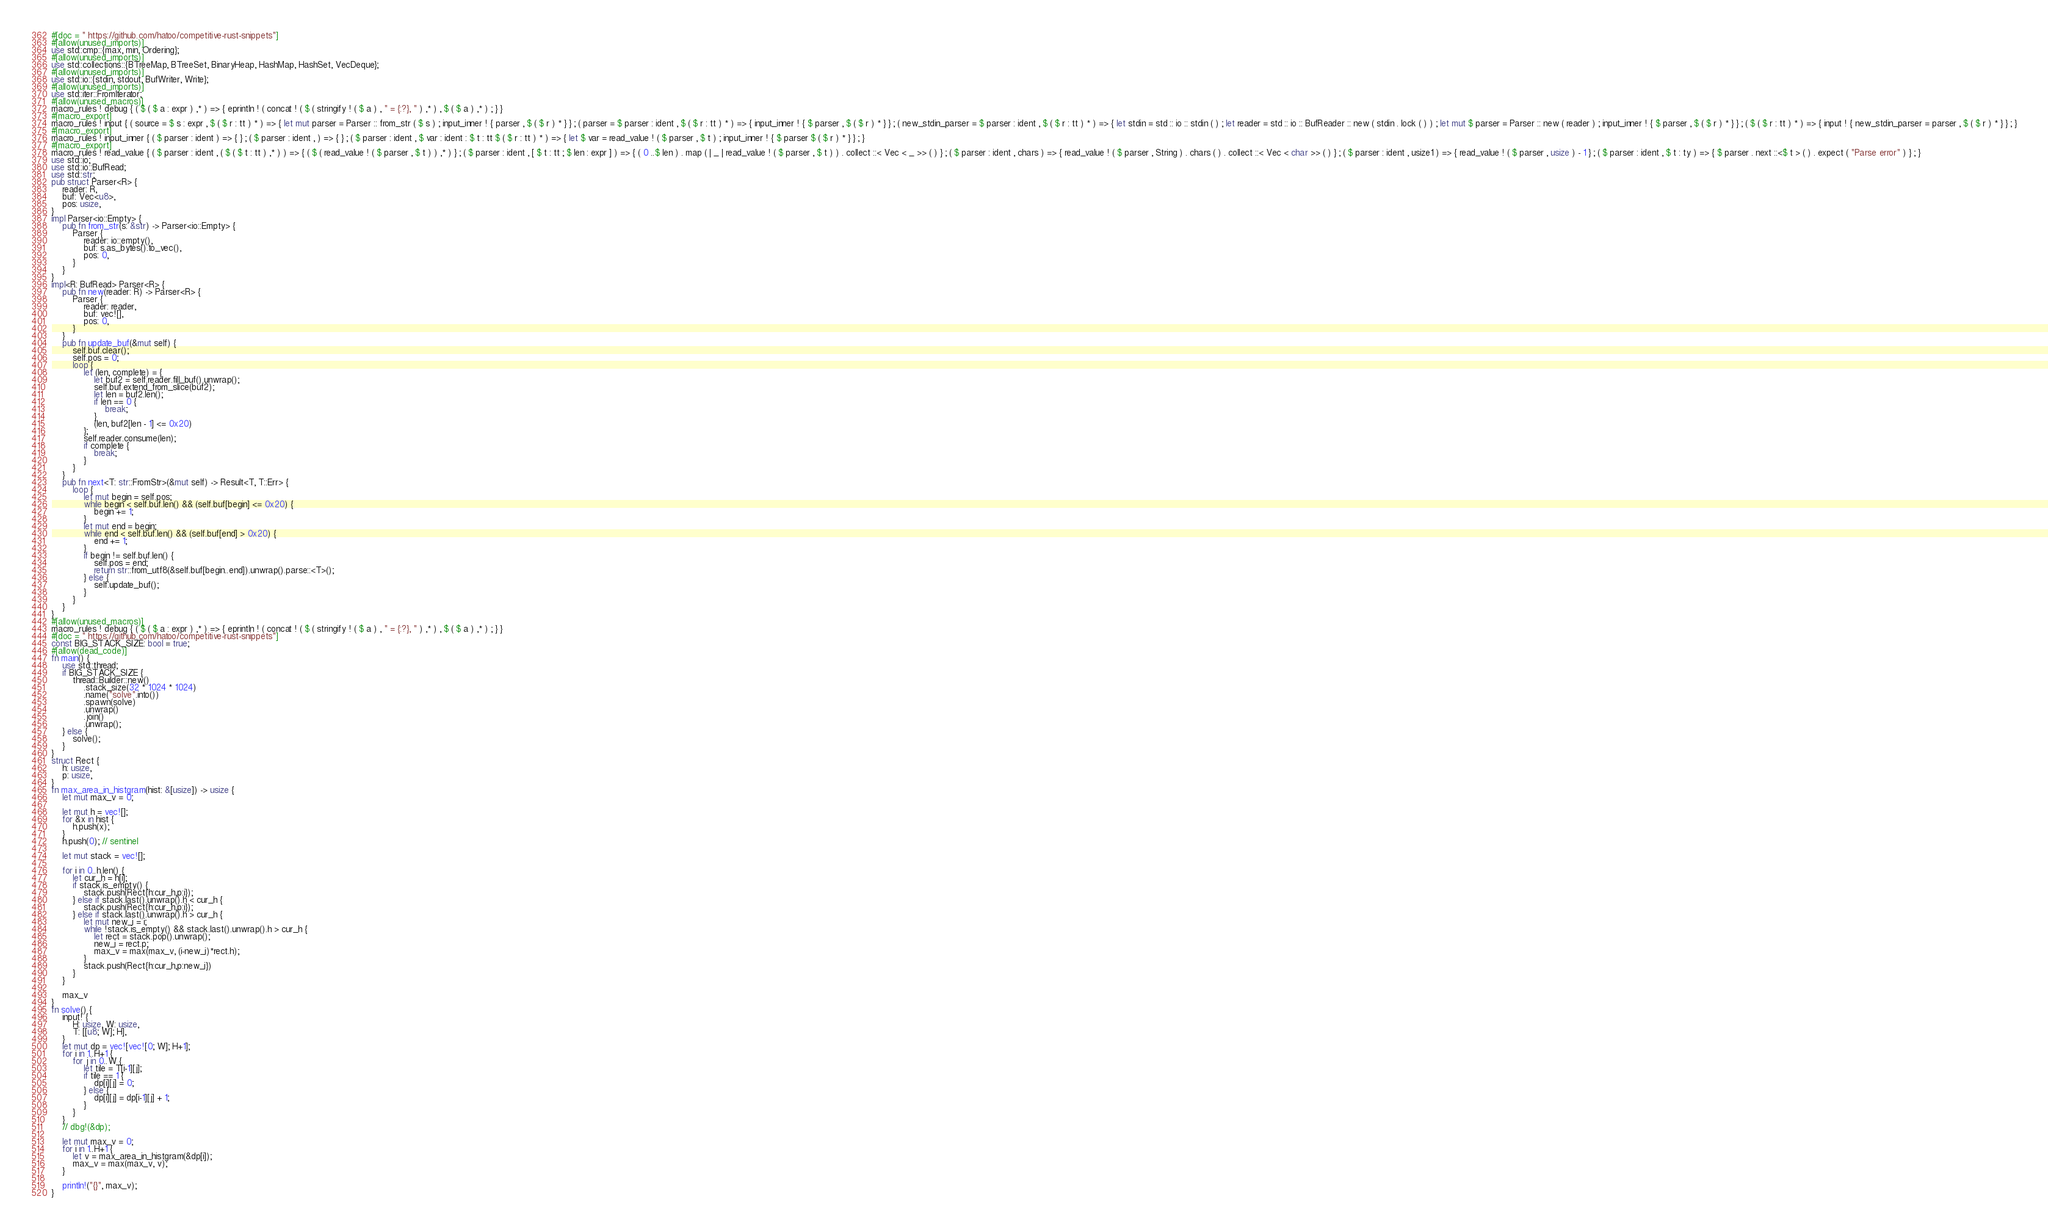<code> <loc_0><loc_0><loc_500><loc_500><_Rust_>#[doc = " https://github.com/hatoo/competitive-rust-snippets"]
#[allow(unused_imports)]
use std::cmp::{max, min, Ordering};
#[allow(unused_imports)]
use std::collections::{BTreeMap, BTreeSet, BinaryHeap, HashMap, HashSet, VecDeque};
#[allow(unused_imports)]
use std::io::{stdin, stdout, BufWriter, Write};
#[allow(unused_imports)]
use std::iter::FromIterator;
#[allow(unused_macros)]
macro_rules ! debug { ( $ ( $ a : expr ) ,* ) => { eprintln ! ( concat ! ( $ ( stringify ! ( $ a ) , " = {:?}, " ) ,* ) , $ ( $ a ) ,* ) ; } }
#[macro_export]
macro_rules ! input { ( source = $ s : expr , $ ( $ r : tt ) * ) => { let mut parser = Parser :: from_str ( $ s ) ; input_inner ! { parser , $ ( $ r ) * } } ; ( parser = $ parser : ident , $ ( $ r : tt ) * ) => { input_inner ! { $ parser , $ ( $ r ) * } } ; ( new_stdin_parser = $ parser : ident , $ ( $ r : tt ) * ) => { let stdin = std :: io :: stdin ( ) ; let reader = std :: io :: BufReader :: new ( stdin . lock ( ) ) ; let mut $ parser = Parser :: new ( reader ) ; input_inner ! { $ parser , $ ( $ r ) * } } ; ( $ ( $ r : tt ) * ) => { input ! { new_stdin_parser = parser , $ ( $ r ) * } } ; }
#[macro_export]
macro_rules ! input_inner { ( $ parser : ident ) => { } ; ( $ parser : ident , ) => { } ; ( $ parser : ident , $ var : ident : $ t : tt $ ( $ r : tt ) * ) => { let $ var = read_value ! ( $ parser , $ t ) ; input_inner ! { $ parser $ ( $ r ) * } } ; }
#[macro_export]
macro_rules ! read_value { ( $ parser : ident , ( $ ( $ t : tt ) ,* ) ) => { ( $ ( read_value ! ( $ parser , $ t ) ) ,* ) } ; ( $ parser : ident , [ $ t : tt ; $ len : expr ] ) => { ( 0 ..$ len ) . map ( | _ | read_value ! ( $ parser , $ t ) ) . collect ::< Vec < _ >> ( ) } ; ( $ parser : ident , chars ) => { read_value ! ( $ parser , String ) . chars ( ) . collect ::< Vec < char >> ( ) } ; ( $ parser : ident , usize1 ) => { read_value ! ( $ parser , usize ) - 1 } ; ( $ parser : ident , $ t : ty ) => { $ parser . next ::<$ t > ( ) . expect ( "Parse error" ) } ; }
use std::io;
use std::io::BufRead;
use std::str;
pub struct Parser<R> {
    reader: R,
    buf: Vec<u8>,
    pos: usize,
}
impl Parser<io::Empty> {
    pub fn from_str(s: &str) -> Parser<io::Empty> {
        Parser {
            reader: io::empty(),
            buf: s.as_bytes().to_vec(),
            pos: 0,
        }
    }
}
impl<R: BufRead> Parser<R> {
    pub fn new(reader: R) -> Parser<R> {
        Parser {
            reader: reader,
            buf: vec![],
            pos: 0,
        }
    }
    pub fn update_buf(&mut self) {
        self.buf.clear();
        self.pos = 0;
        loop {
            let (len, complete) = {
                let buf2 = self.reader.fill_buf().unwrap();
                self.buf.extend_from_slice(buf2);
                let len = buf2.len();
                if len == 0 {
                    break;
                }
                (len, buf2[len - 1] <= 0x20)
            };
            self.reader.consume(len);
            if complete {
                break;
            }
        }
    }
    pub fn next<T: str::FromStr>(&mut self) -> Result<T, T::Err> {
        loop {
            let mut begin = self.pos;
            while begin < self.buf.len() && (self.buf[begin] <= 0x20) {
                begin += 1;
            }
            let mut end = begin;
            while end < self.buf.len() && (self.buf[end] > 0x20) {
                end += 1;
            }
            if begin != self.buf.len() {
                self.pos = end;
                return str::from_utf8(&self.buf[begin..end]).unwrap().parse::<T>();
            } else {
                self.update_buf();
            }
        }
    }
}
#[allow(unused_macros)]
macro_rules ! debug { ( $ ( $ a : expr ) ,* ) => { eprintln ! ( concat ! ( $ ( stringify ! ( $ a ) , " = {:?}, " ) ,* ) , $ ( $ a ) ,* ) ; } }
#[doc = " https://github.com/hatoo/competitive-rust-snippets"]
const BIG_STACK_SIZE: bool = true;
#[allow(dead_code)]
fn main() {
    use std::thread;
    if BIG_STACK_SIZE {
        thread::Builder::new()
            .stack_size(32 * 1024 * 1024)
            .name("solve".into())
            .spawn(solve)
            .unwrap()
            .join()
            .unwrap();
    } else {
        solve();
    }
}
struct Rect {
    h: usize,
    p: usize,
}
fn max_area_in_histgram(hist: &[usize]) -> usize {
    let mut max_v = 0;

    let mut h = vec![];
    for &x in hist {
        h.push(x);
    }
    h.push(0); // sentinel

    let mut stack = vec![];

    for i in 0..h.len() {
        let cur_h = h[i];
        if stack.is_empty() {
            stack.push(Rect{h:cur_h,p:i});
        } else if stack.last().unwrap().h < cur_h {
            stack.push(Rect{h:cur_h,p:i});
        } else if stack.last().unwrap().h > cur_h {
            let mut new_i = i;
            while !stack.is_empty() && stack.last().unwrap().h > cur_h {
                let rect = stack.pop().unwrap();
                new_i = rect.p;
                max_v = max(max_v, (i-new_i)*rect.h);
            }
            stack.push(Rect{h:cur_h,p:new_i})
        }
    }

    max_v
}
fn solve() {
    input! {
        H: usize, W: usize,
        T: [[u8; W]; H],
    }
    let mut dp = vec![vec![0; W]; H+1];
    for i in 1..H+1 {
        for j in 0..W {
            let tile = T[i-1][j];
            if tile == 1 {
                dp[i][j] = 0;
            } else {
                dp[i][j] = dp[i-1][j] + 1;
            }
        }
    }
    // dbg!(&dp);

    let mut max_v = 0;
    for i in 1..H+1 {
        let v = max_area_in_histgram(&dp[i]);
        max_v = max(max_v, v);
    }

    println!("{}", max_v);
}
</code> 